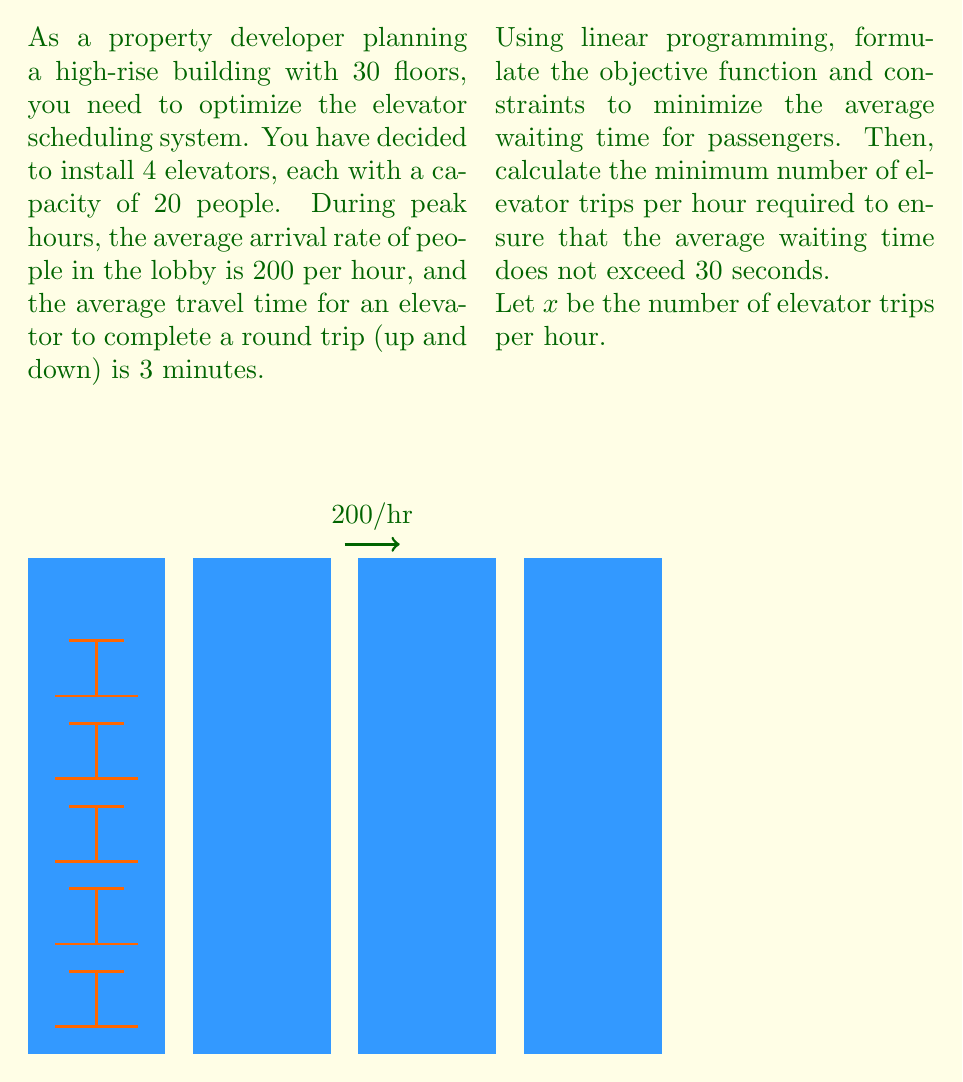Could you help me with this problem? Let's approach this problem step by step:

1) First, we need to set up the objective function. We want to minimize the average waiting time. According to queueing theory, the average waiting time is inversely proportional to the service rate minus the arrival rate. Therefore, our objective function is:

   Minimize $\frac{1}{x - \frac{200}{60}}$

2) Now, let's set up the constraints:

   a) The number of trips can't be negative: $x \geq 0$
   
   b) The elevators can't make more trips than physically possible:
      Each elevator can make at most $\frac{60}{3} = 20$ trips per hour.
      With 4 elevators: $x \leq 4 * 20 = 80$

   c) The elevators must be able to carry all arriving passengers:
      $20x \geq 200$ (capacity per trip * trips per hour ≥ arrivals per hour)

3) To find the minimum number of trips required to keep the average waiting time under 30 seconds, we set up the inequality:

   $\frac{1}{x - \frac{200}{60}} \leq \frac{30}{3600}$

4) Solving this inequality:

   $\frac{1}{x - \frac{10}{3}} \leq \frac{1}{120}$
   
   $120 \leq x - \frac{10}{3}$
   
   $\frac{370}{3} \leq x$

5) Therefore, we need at least $\frac{370}{3} \approx 123.33$ trips per hour.

6) Since we can only have a whole number of trips, we round up to 124 trips per hour.

7) Checking our constraints:
   - 124 ≥ 0 (satisfied)
   - 124 ≤ 80 (not satisfied, but this is our minimum required)
   - 20 * 124 = 2480 ≥ 200 (satisfied)

Therefore, the minimum number of elevator trips per hour required is 124.
Answer: 124 trips per hour 